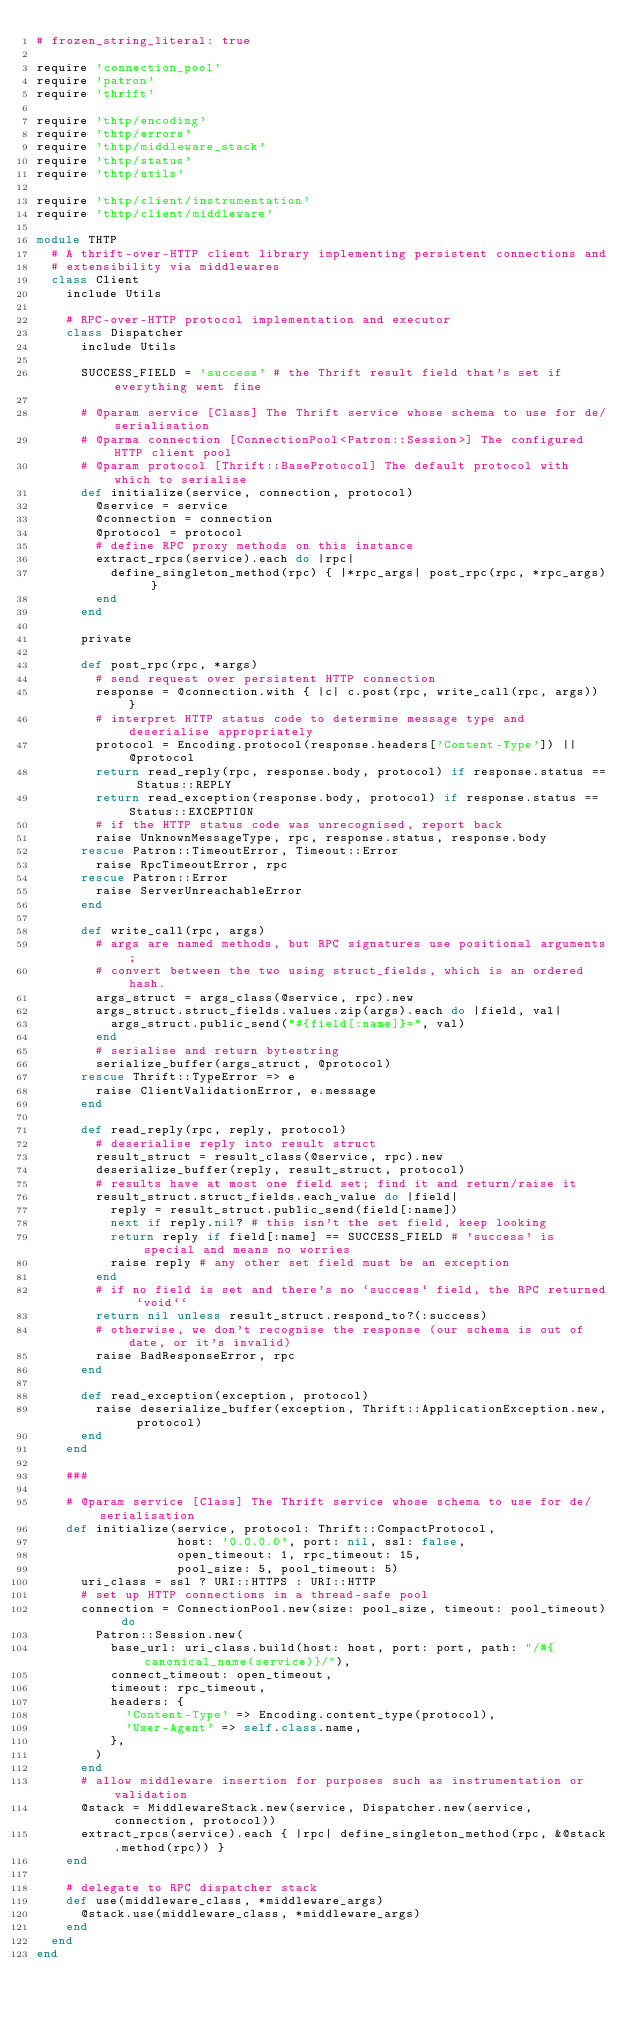<code> <loc_0><loc_0><loc_500><loc_500><_Ruby_># frozen_string_literal: true

require 'connection_pool'
require 'patron'
require 'thrift'

require 'thtp/encoding'
require 'thtp/errors'
require 'thtp/middleware_stack'
require 'thtp/status'
require 'thtp/utils'

require 'thtp/client/instrumentation'
require 'thtp/client/middleware'

module THTP
  # A thrift-over-HTTP client library implementing persistent connections and
  # extensibility via middlewares
  class Client
    include Utils

    # RPC-over-HTTP protocol implementation and executor
    class Dispatcher
      include Utils

      SUCCESS_FIELD = 'success' # the Thrift result field that's set if everything went fine

      # @param service [Class] The Thrift service whose schema to use for de/serialisation
      # @parma connection [ConnectionPool<Patron::Session>] The configured HTTP client pool
      # @param protocol [Thrift::BaseProtocol] The default protocol with which to serialise
      def initialize(service, connection, protocol)
        @service = service
        @connection = connection
        @protocol = protocol
        # define RPC proxy methods on this instance
        extract_rpcs(service).each do |rpc|
          define_singleton_method(rpc) { |*rpc_args| post_rpc(rpc, *rpc_args) }
        end
      end

      private

      def post_rpc(rpc, *args)
        # send request over persistent HTTP connection
        response = @connection.with { |c| c.post(rpc, write_call(rpc, args)) }
        # interpret HTTP status code to determine message type and deserialise appropriately
        protocol = Encoding.protocol(response.headers['Content-Type']) || @protocol
        return read_reply(rpc, response.body, protocol) if response.status == Status::REPLY
        return read_exception(response.body, protocol) if response.status == Status::EXCEPTION
        # if the HTTP status code was unrecognised, report back
        raise UnknownMessageType, rpc, response.status, response.body
      rescue Patron::TimeoutError, Timeout::Error
        raise RpcTimeoutError, rpc
      rescue Patron::Error
        raise ServerUnreachableError
      end

      def write_call(rpc, args)
        # args are named methods, but RPC signatures use positional arguments;
        # convert between the two using struct_fields, which is an ordered hash.
        args_struct = args_class(@service, rpc).new
        args_struct.struct_fields.values.zip(args).each do |field, val|
          args_struct.public_send("#{field[:name]}=", val)
        end
        # serialise and return bytestring
        serialize_buffer(args_struct, @protocol)
      rescue Thrift::TypeError => e
        raise ClientValidationError, e.message
      end

      def read_reply(rpc, reply, protocol)
        # deserialise reply into result struct
        result_struct = result_class(@service, rpc).new
        deserialize_buffer(reply, result_struct, protocol)
        # results have at most one field set; find it and return/raise it
        result_struct.struct_fields.each_value do |field|
          reply = result_struct.public_send(field[:name])
          next if reply.nil? # this isn't the set field, keep looking
          return reply if field[:name] == SUCCESS_FIELD # 'success' is special and means no worries
          raise reply # any other set field must be an exception
        end
        # if no field is set and there's no `success` field, the RPC returned `void``
        return nil unless result_struct.respond_to?(:success)
        # otherwise, we don't recognise the response (our schema is out of date, or it's invalid)
        raise BadResponseError, rpc
      end

      def read_exception(exception, protocol)
        raise deserialize_buffer(exception, Thrift::ApplicationException.new, protocol)
      end
    end

    ###

    # @param service [Class] The Thrift service whose schema to use for de/serialisation
    def initialize(service, protocol: Thrift::CompactProtocol,
                   host: '0.0.0.0', port: nil, ssl: false,
                   open_timeout: 1, rpc_timeout: 15,
                   pool_size: 5, pool_timeout: 5)
      uri_class = ssl ? URI::HTTPS : URI::HTTP
      # set up HTTP connections in a thread-safe pool
      connection = ConnectionPool.new(size: pool_size, timeout: pool_timeout) do
        Patron::Session.new(
          base_url: uri_class.build(host: host, port: port, path: "/#{canonical_name(service)}/"),
          connect_timeout: open_timeout,
          timeout: rpc_timeout,
          headers: {
            'Content-Type' => Encoding.content_type(protocol),
            'User-Agent' => self.class.name,
          },
        )
      end
      # allow middleware insertion for purposes such as instrumentation or validation
      @stack = MiddlewareStack.new(service, Dispatcher.new(service, connection, protocol))
      extract_rpcs(service).each { |rpc| define_singleton_method(rpc, &@stack.method(rpc)) }
    end

    # delegate to RPC dispatcher stack
    def use(middleware_class, *middleware_args)
      @stack.use(middleware_class, *middleware_args)
    end
  end
end
</code> 